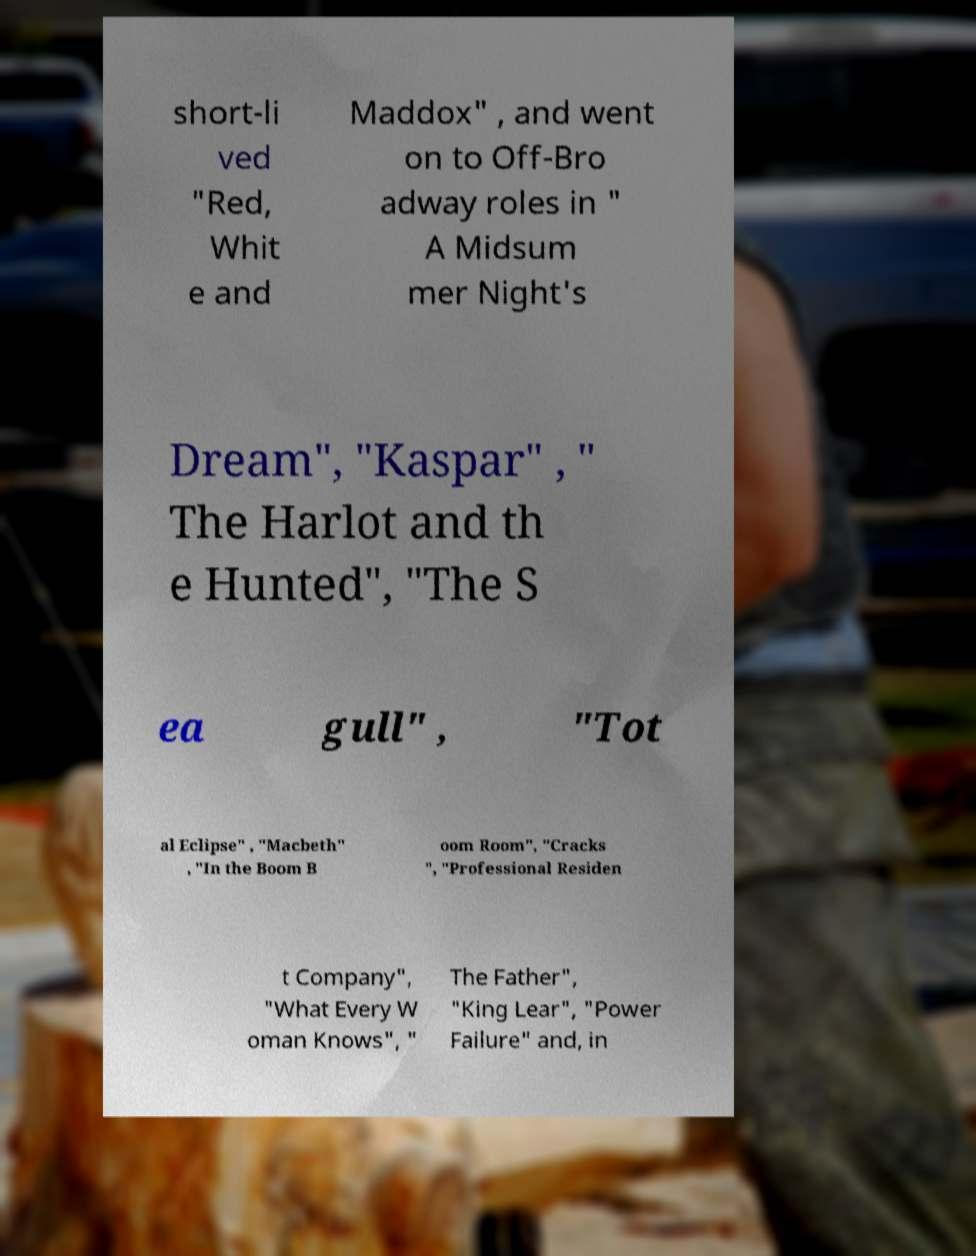I need the written content from this picture converted into text. Can you do that? short-li ved "Red, Whit e and Maddox" , and went on to Off-Bro adway roles in " A Midsum mer Night's Dream", "Kaspar" , " The Harlot and th e Hunted", "The S ea gull" , "Tot al Eclipse" , "Macbeth" , "In the Boom B oom Room", "Cracks ", "Professional Residen t Company", "What Every W oman Knows", " The Father", "King Lear", "Power Failure" and, in 